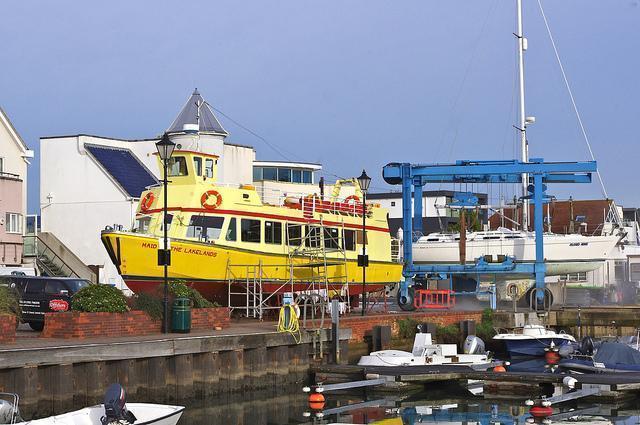What are the red planters on the left made from?
Choose the correct response, then elucidate: 'Answer: answer
Rationale: rationale.'
Options: Metal, aluminum, bricks, plastic. Answer: bricks.
Rationale: The red planters on the left are made of brick material. 